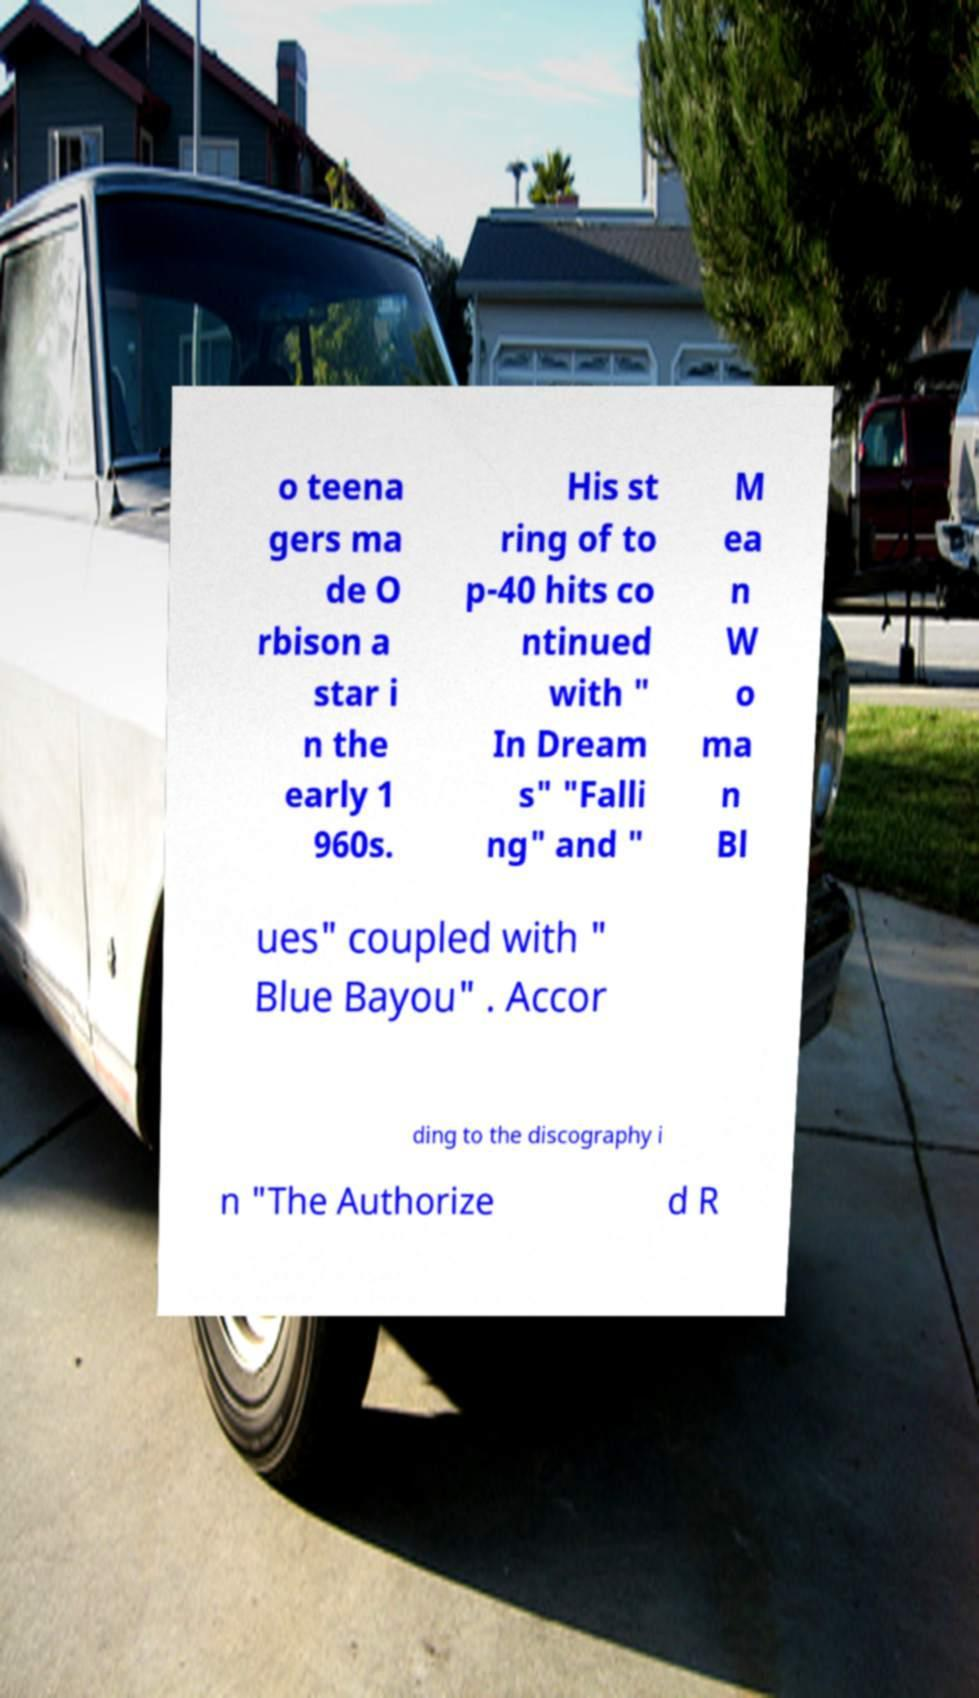Please read and relay the text visible in this image. What does it say? o teena gers ma de O rbison a star i n the early 1 960s. His st ring of to p-40 hits co ntinued with " In Dream s" "Falli ng" and " M ea n W o ma n Bl ues" coupled with " Blue Bayou" . Accor ding to the discography i n "The Authorize d R 